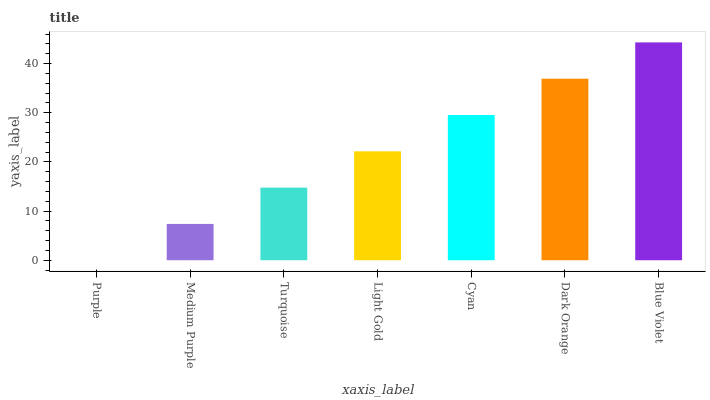Is Purple the minimum?
Answer yes or no. Yes. Is Blue Violet the maximum?
Answer yes or no. Yes. Is Medium Purple the minimum?
Answer yes or no. No. Is Medium Purple the maximum?
Answer yes or no. No. Is Medium Purple greater than Purple?
Answer yes or no. Yes. Is Purple less than Medium Purple?
Answer yes or no. Yes. Is Purple greater than Medium Purple?
Answer yes or no. No. Is Medium Purple less than Purple?
Answer yes or no. No. Is Light Gold the high median?
Answer yes or no. Yes. Is Light Gold the low median?
Answer yes or no. Yes. Is Purple the high median?
Answer yes or no. No. Is Dark Orange the low median?
Answer yes or no. No. 